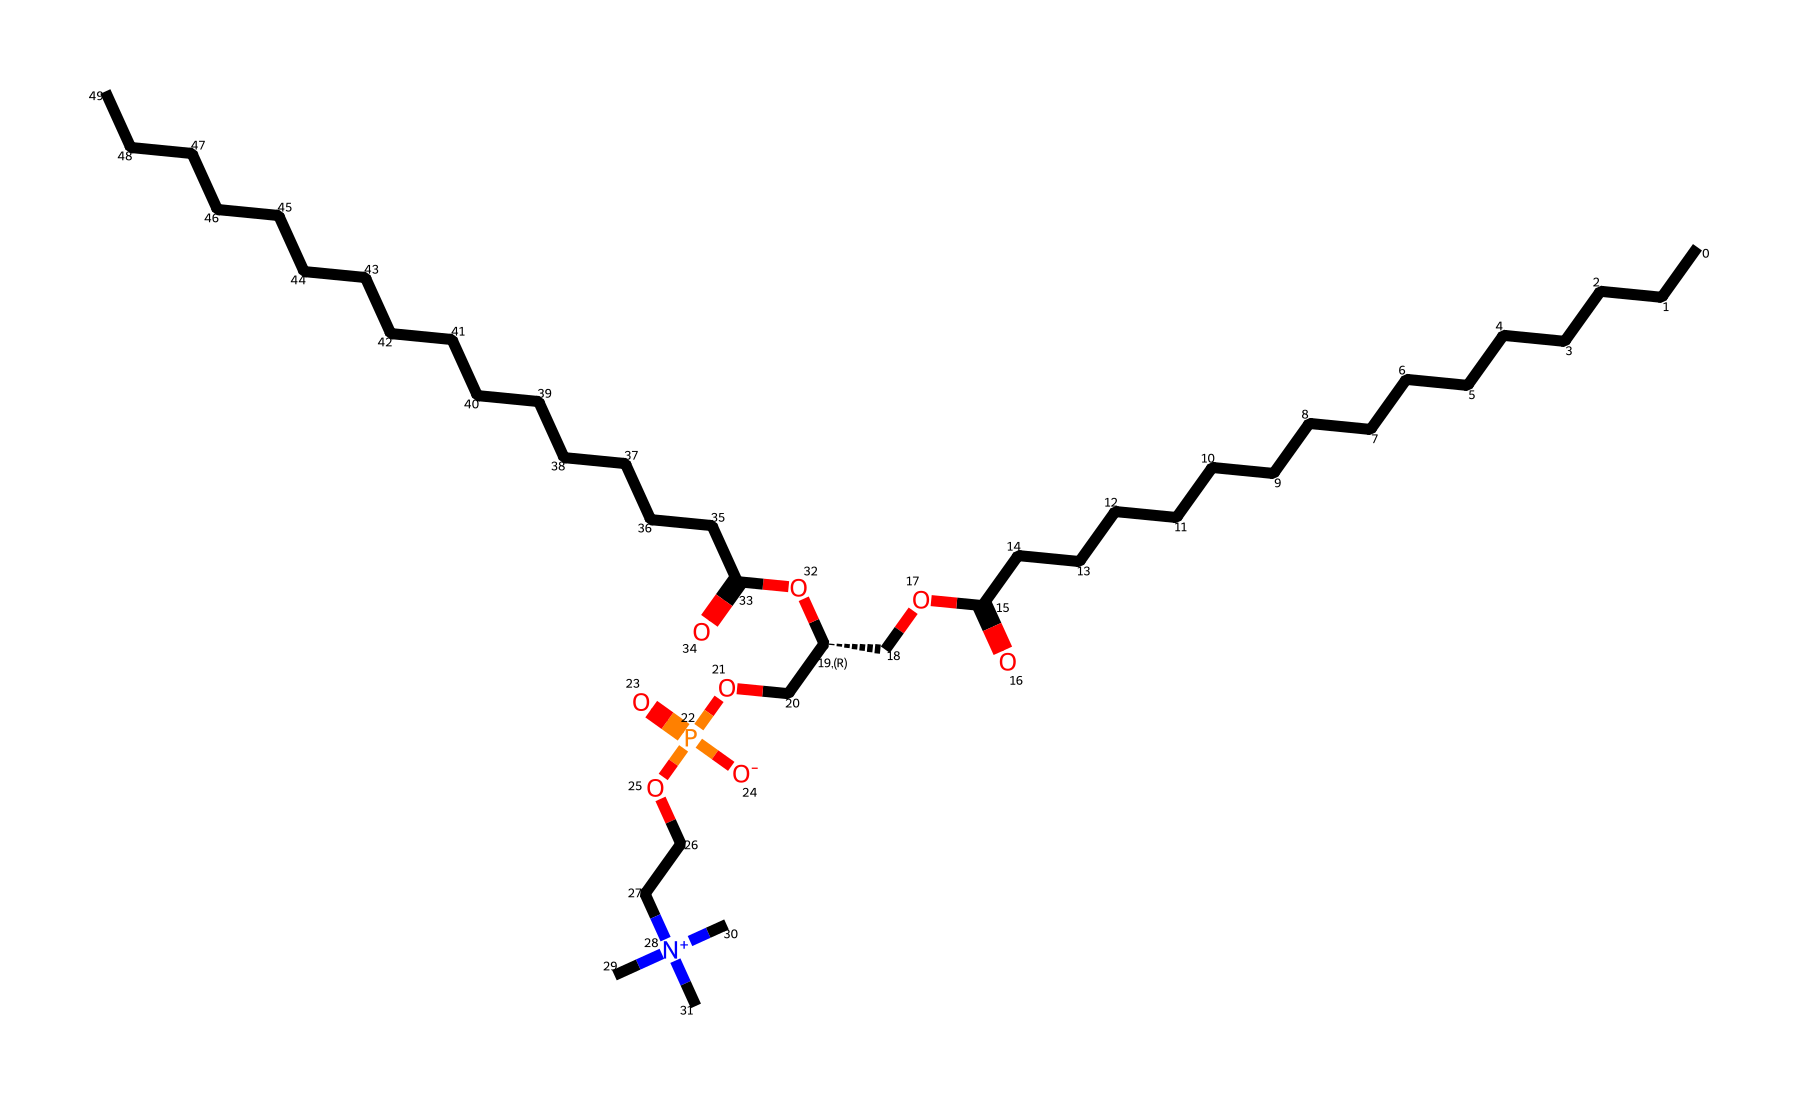What is the main functional group present in phosphatidylcholine? The main functional group in phosphatidylcholine is the phosphate group, which contains phosphorus and is pivotal in its role as a phospholipid.
Answer: phosphate group How many carbon atoms are in the phosphatidylcholine structure? By examining the carbon chain and identifying the carbon atoms within the structure, we can count a total of 22 carbon atoms.
Answer: 22 What is the total number of oxygen atoms in this phosphatidylcholine structure? By analyzing the SMILES representation, we can identify that there are 6 oxygen atoms present in the entire structure.
Answer: 6 What type of molecule is phosphatidylcholine classified as? Phosphatidylcholine is classified as a phospholipid, which is a type of lipid molecule containing a phosphate group.
Answer: phospholipid What characteristic of phosphatidylcholine allows it to form cell membranes? The amphiphilic nature of phosphatidylcholine, due to its hydrophilic head (phosphate group) and hydrophobic tail (long carbon chains), enables it to form bilayers in cell membranes.
Answer: amphiphilic What role does the nitrogen atom play in phosphatidylcholine? The nitrogen atom, as part of the choline component, contributes to the positive charge of the molecule, influencing its interactions and properties in biological membranes.
Answer: positive charge 